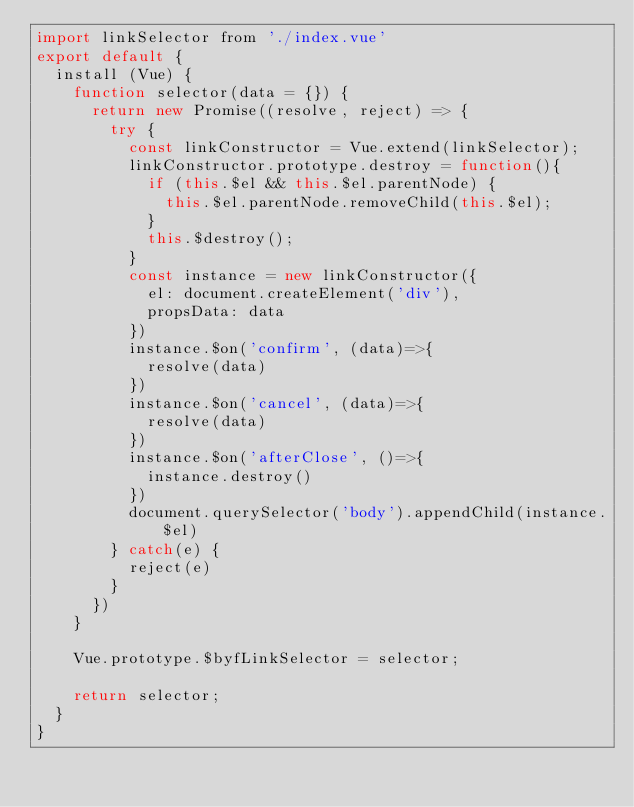Convert code to text. <code><loc_0><loc_0><loc_500><loc_500><_JavaScript_>import linkSelector from './index.vue'
export default {
  install (Vue) {
    function selector(data = {}) {
      return new Promise((resolve, reject) => {
        try {
          const linkConstructor = Vue.extend(linkSelector);
          linkConstructor.prototype.destroy = function(){
            if (this.$el && this.$el.parentNode) {
              this.$el.parentNode.removeChild(this.$el);
            }
            this.$destroy();
          }
          const instance = new linkConstructor({
            el: document.createElement('div'),
            propsData: data
          })
          instance.$on('confirm', (data)=>{
            resolve(data)
          })
          instance.$on('cancel', (data)=>{
            resolve(data)
          })
          instance.$on('afterClose', ()=>{
            instance.destroy()
          })
          document.querySelector('body').appendChild(instance.$el)
        } catch(e) {
          reject(e)
        }
      })
    }

    Vue.prototype.$byfLinkSelector = selector;

    return selector;
  }
}</code> 